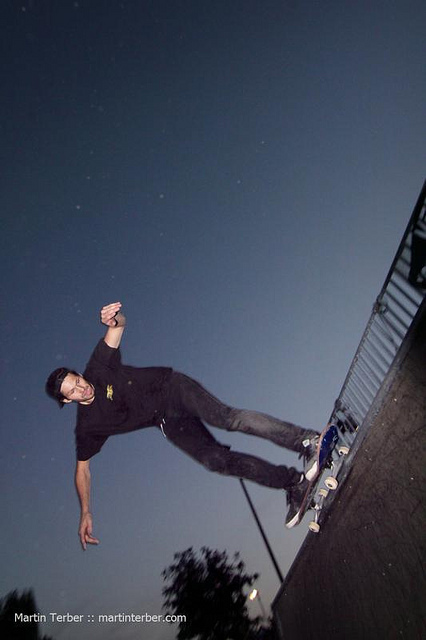Identify the text contained in this image. Martin Terber martinterber. com 